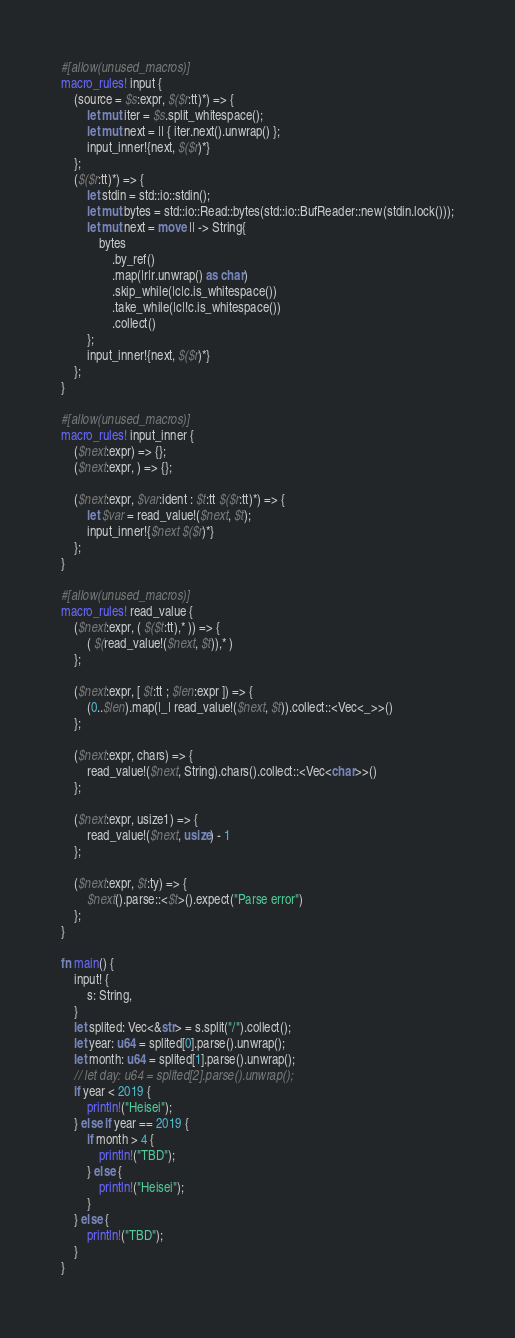Convert code to text. <code><loc_0><loc_0><loc_500><loc_500><_Rust_>#[allow(unused_macros)]
macro_rules! input {
    (source = $s:expr, $($r:tt)*) => {
        let mut iter = $s.split_whitespace();
        let mut next = || { iter.next().unwrap() };
        input_inner!{next, $($r)*}
    };
    ($($r:tt)*) => {
        let stdin = std::io::stdin();
        let mut bytes = std::io::Read::bytes(std::io::BufReader::new(stdin.lock()));
        let mut next = move || -> String{
            bytes
                .by_ref()
                .map(|r|r.unwrap() as char)
                .skip_while(|c|c.is_whitespace())
                .take_while(|c|!c.is_whitespace())
                .collect()
        };
        input_inner!{next, $($r)*}
    };
}

#[allow(unused_macros)]
macro_rules! input_inner {
    ($next:expr) => {};
    ($next:expr, ) => {};

    ($next:expr, $var:ident : $t:tt $($r:tt)*) => {
        let $var = read_value!($next, $t);
        input_inner!{$next $($r)*}
    };
}

#[allow(unused_macros)]
macro_rules! read_value {
    ($next:expr, ( $($t:tt),* )) => {
        ( $(read_value!($next, $t)),* )
    };

    ($next:expr, [ $t:tt ; $len:expr ]) => {
        (0..$len).map(|_| read_value!($next, $t)).collect::<Vec<_>>()
    };

    ($next:expr, chars) => {
        read_value!($next, String).chars().collect::<Vec<char>>()
    };

    ($next:expr, usize1) => {
        read_value!($next, usize) - 1
    };

    ($next:expr, $t:ty) => {
        $next().parse::<$t>().expect("Parse error")
    };
}

fn main() {
    input! {
        s: String,
    }
    let splited: Vec<&str> = s.split("/").collect();
    let year: u64 = splited[0].parse().unwrap();
    let month: u64 = splited[1].parse().unwrap();
    // let day: u64 = splited[2].parse().unwrap();
    if year < 2019 {
        println!("Heisei");
    } else if year == 2019 {
        if month > 4 {
            println!("TBD");
        } else {
            println!("Heisei");
        }
    } else {
        println!("TBD");
    }
}
</code> 